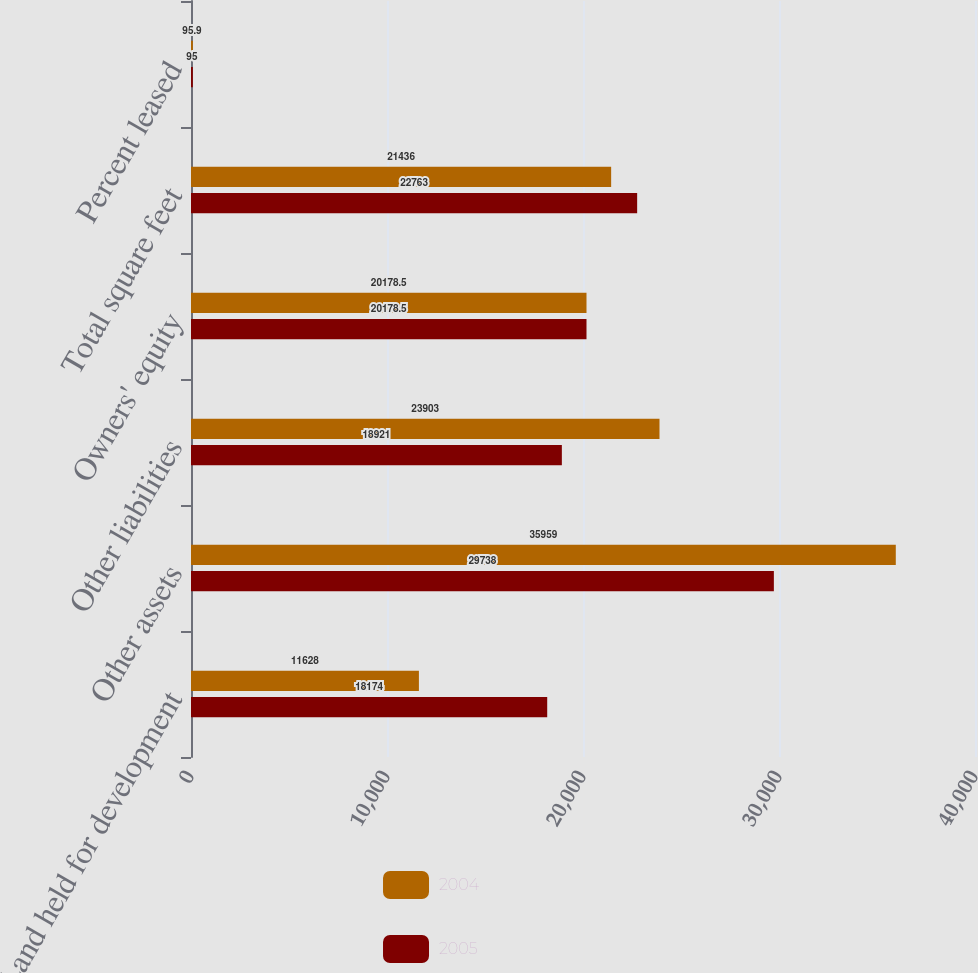Convert chart to OTSL. <chart><loc_0><loc_0><loc_500><loc_500><stacked_bar_chart><ecel><fcel>Land held for development<fcel>Other assets<fcel>Other liabilities<fcel>Owners' equity<fcel>Total square feet<fcel>Percent leased<nl><fcel>2004<fcel>11628<fcel>35959<fcel>23903<fcel>20178.5<fcel>21436<fcel>95.9<nl><fcel>2005<fcel>18174<fcel>29738<fcel>18921<fcel>20178.5<fcel>22763<fcel>95<nl></chart> 